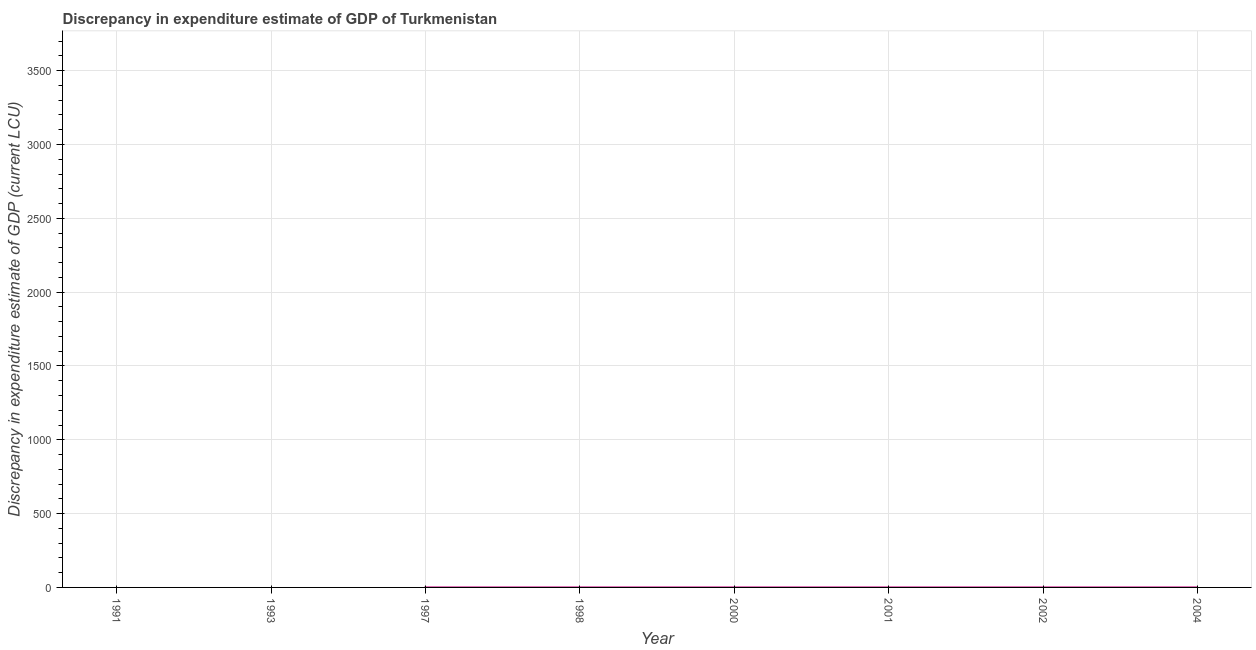What is the discrepancy in expenditure estimate of gdp in 2004?
Ensure brevity in your answer.  0. Across all years, what is the maximum discrepancy in expenditure estimate of gdp?
Your answer should be compact. 0. Across all years, what is the minimum discrepancy in expenditure estimate of gdp?
Keep it short and to the point. 0. In which year was the discrepancy in expenditure estimate of gdp maximum?
Give a very brief answer. 1997. What is the sum of the discrepancy in expenditure estimate of gdp?
Ensure brevity in your answer.  0. What is the difference between the discrepancy in expenditure estimate of gdp in 2001 and 2004?
Give a very brief answer. -3.9999999999999617e-7. What is the average discrepancy in expenditure estimate of gdp per year?
Your answer should be compact. 5.003625e-5. What is the median discrepancy in expenditure estimate of gdp?
Offer a very short reply. 4.9999999999999996e-5. In how many years, is the discrepancy in expenditure estimate of gdp greater than 1700 LCU?
Make the answer very short. 0. What is the ratio of the discrepancy in expenditure estimate of gdp in 1998 to that in 2000?
Your answer should be compact. 333.5. Is the discrepancy in expenditure estimate of gdp in 1998 less than that in 2004?
Ensure brevity in your answer.  Yes. What is the difference between the highest and the second highest discrepancy in expenditure estimate of gdp?
Your answer should be very brief. 4.000000000000639e-8. What is the difference between the highest and the lowest discrepancy in expenditure estimate of gdp?
Offer a terse response. 0. Does the discrepancy in expenditure estimate of gdp monotonically increase over the years?
Give a very brief answer. No. How many years are there in the graph?
Your answer should be compact. 8. Are the values on the major ticks of Y-axis written in scientific E-notation?
Keep it short and to the point. No. Does the graph contain any zero values?
Provide a succinct answer. Yes. What is the title of the graph?
Offer a terse response. Discrepancy in expenditure estimate of GDP of Turkmenistan. What is the label or title of the Y-axis?
Give a very brief answer. Discrepancy in expenditure estimate of GDP (current LCU). What is the Discrepancy in expenditure estimate of GDP (current LCU) of 1991?
Give a very brief answer. 0. What is the Discrepancy in expenditure estimate of GDP (current LCU) in 1993?
Provide a succinct answer. 0. What is the Discrepancy in expenditure estimate of GDP (current LCU) in 1997?
Keep it short and to the point. 0. What is the Discrepancy in expenditure estimate of GDP (current LCU) of 1998?
Keep it short and to the point. 0. What is the Discrepancy in expenditure estimate of GDP (current LCU) of 2000?
Keep it short and to the point. 3e-7. What is the Discrepancy in expenditure estimate of GDP (current LCU) of 2001?
Keep it short and to the point. 9.97e-5. What is the Discrepancy in expenditure estimate of GDP (current LCU) in 2002?
Provide a succinct answer. 0. What is the Discrepancy in expenditure estimate of GDP (current LCU) in 2004?
Offer a terse response. 0. What is the difference between the Discrepancy in expenditure estimate of GDP (current LCU) in 1997 and 1998?
Provide a succinct answer. 0. What is the difference between the Discrepancy in expenditure estimate of GDP (current LCU) in 1997 and 2001?
Give a very brief answer. 0. What is the difference between the Discrepancy in expenditure estimate of GDP (current LCU) in 1998 and 2000?
Your response must be concise. 0. What is the difference between the Discrepancy in expenditure estimate of GDP (current LCU) in 2000 and 2001?
Your answer should be very brief. -0. What is the difference between the Discrepancy in expenditure estimate of GDP (current LCU) in 2000 and 2004?
Provide a short and direct response. -0. What is the ratio of the Discrepancy in expenditure estimate of GDP (current LCU) in 1997 to that in 1998?
Your answer should be very brief. 1. What is the ratio of the Discrepancy in expenditure estimate of GDP (current LCU) in 1997 to that in 2000?
Your answer should be compact. 333.8. What is the ratio of the Discrepancy in expenditure estimate of GDP (current LCU) in 1997 to that in 2004?
Your response must be concise. 1. What is the ratio of the Discrepancy in expenditure estimate of GDP (current LCU) in 1998 to that in 2000?
Give a very brief answer. 333.5. What is the ratio of the Discrepancy in expenditure estimate of GDP (current LCU) in 1998 to that in 2001?
Keep it short and to the point. 1. What is the ratio of the Discrepancy in expenditure estimate of GDP (current LCU) in 2000 to that in 2001?
Make the answer very short. 0. What is the ratio of the Discrepancy in expenditure estimate of GDP (current LCU) in 2000 to that in 2004?
Give a very brief answer. 0. 